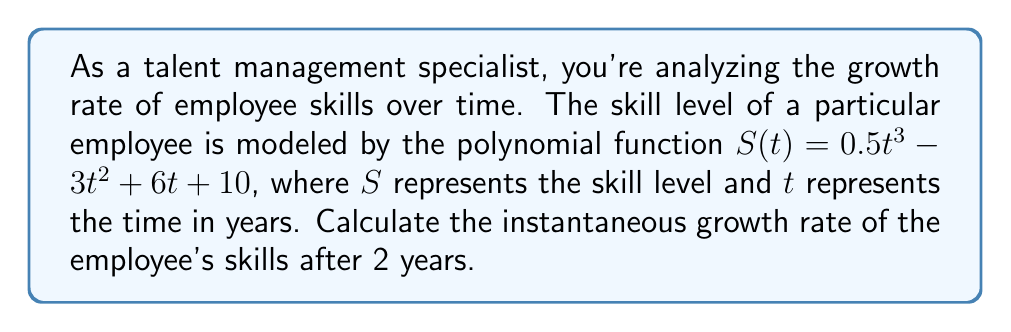Teach me how to tackle this problem. To find the instantaneous growth rate of the employee's skills after 2 years, we need to follow these steps:

1) The instantaneous growth rate is given by the derivative of the skill function $S(t)$ at $t = 2$.

2) First, let's find the derivative of $S(t)$:
   $$S(t) = 0.5t^3 - 3t^2 + 6t + 10$$
   $$S'(t) = 1.5t^2 - 6t + 6$$

3) Now, we need to evaluate $S'(t)$ at $t = 2$:
   $$S'(2) = 1.5(2)^2 - 6(2) + 6$$
   $$S'(2) = 1.5(4) - 12 + 6$$
   $$S'(2) = 6 - 12 + 6$$
   $$S'(2) = 0$$

4) Therefore, the instantaneous growth rate of the employee's skills after 2 years is 0 units per year.

This means that at exactly 2 years, the employee's skill level is momentarily neither increasing nor decreasing.
Answer: 0 units per year 